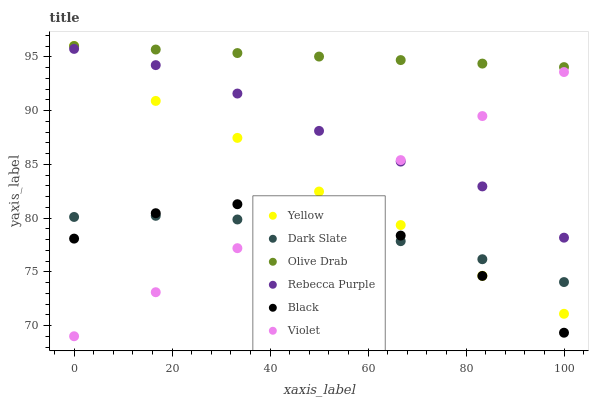Does Black have the minimum area under the curve?
Answer yes or no. Yes. Does Olive Drab have the maximum area under the curve?
Answer yes or no. Yes. Does Dark Slate have the minimum area under the curve?
Answer yes or no. No. Does Dark Slate have the maximum area under the curve?
Answer yes or no. No. Is Olive Drab the smoothest?
Answer yes or no. Yes. Is Yellow the roughest?
Answer yes or no. Yes. Is Dark Slate the smoothest?
Answer yes or no. No. Is Dark Slate the roughest?
Answer yes or no. No. Does Violet have the lowest value?
Answer yes or no. Yes. Does Dark Slate have the lowest value?
Answer yes or no. No. Does Olive Drab have the highest value?
Answer yes or no. Yes. Does Black have the highest value?
Answer yes or no. No. Is Dark Slate less than Olive Drab?
Answer yes or no. Yes. Is Rebecca Purple greater than Dark Slate?
Answer yes or no. Yes. Does Olive Drab intersect Yellow?
Answer yes or no. Yes. Is Olive Drab less than Yellow?
Answer yes or no. No. Is Olive Drab greater than Yellow?
Answer yes or no. No. Does Dark Slate intersect Olive Drab?
Answer yes or no. No. 